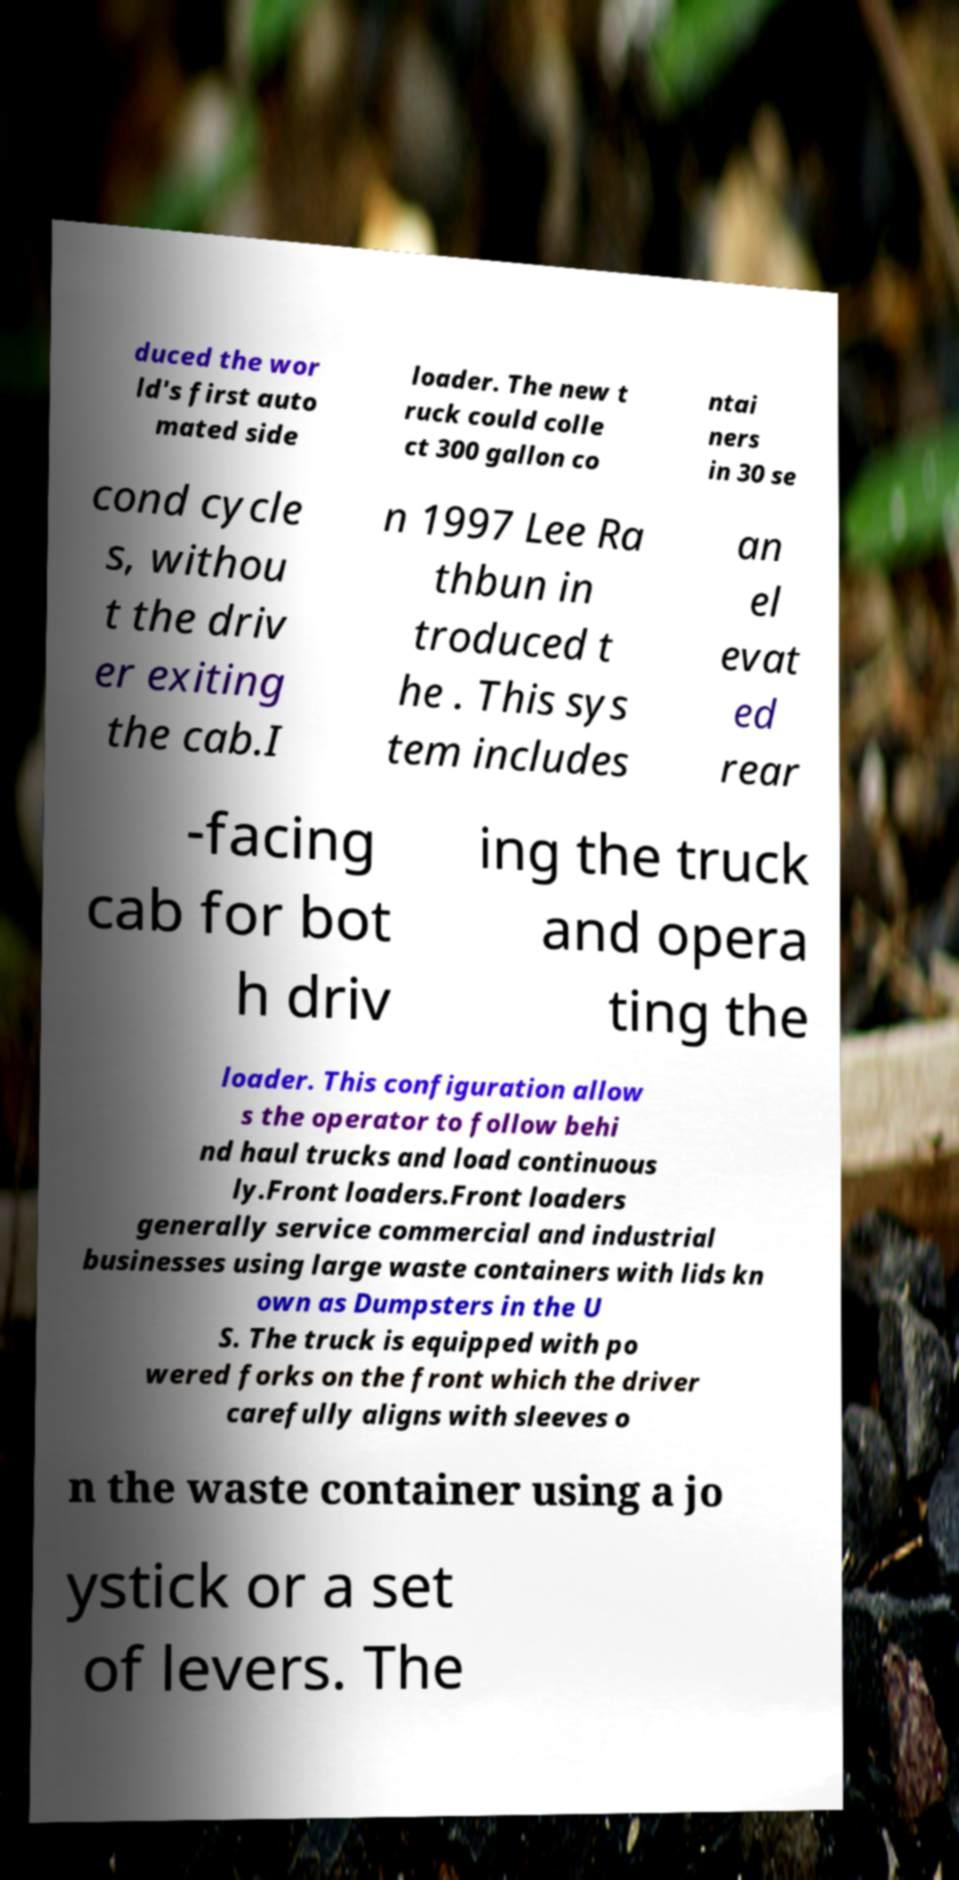I need the written content from this picture converted into text. Can you do that? duced the wor ld's first auto mated side loader. The new t ruck could colle ct 300 gallon co ntai ners in 30 se cond cycle s, withou t the driv er exiting the cab.I n 1997 Lee Ra thbun in troduced t he . This sys tem includes an el evat ed rear -facing cab for bot h driv ing the truck and opera ting the loader. This configuration allow s the operator to follow behi nd haul trucks and load continuous ly.Front loaders.Front loaders generally service commercial and industrial businesses using large waste containers with lids kn own as Dumpsters in the U S. The truck is equipped with po wered forks on the front which the driver carefully aligns with sleeves o n the waste container using a jo ystick or a set of levers. The 